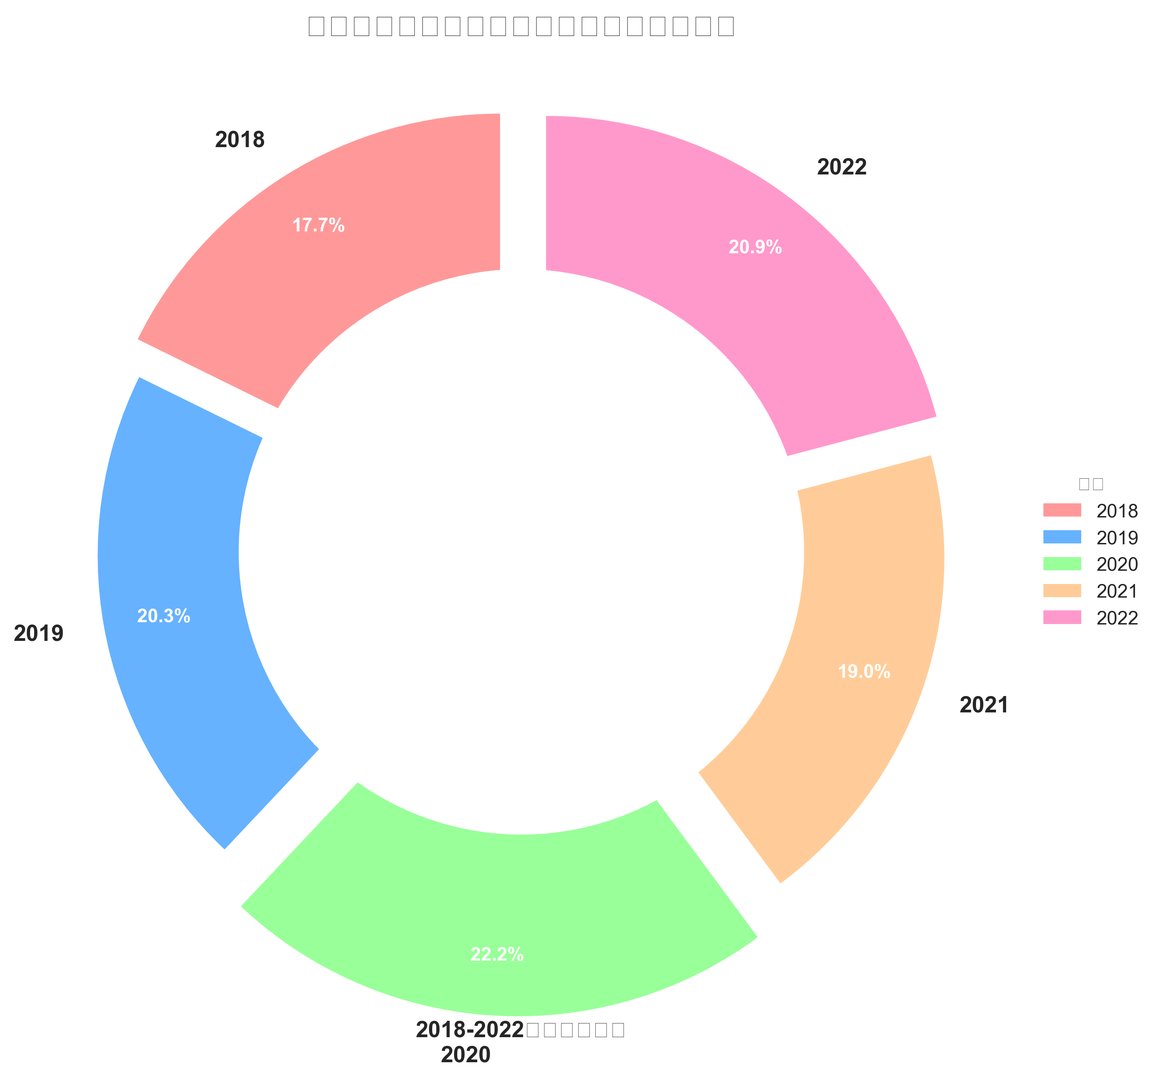五月天專輯銷量在2020年的份額是多少？ 在圖表中，我們可以看到2020年這個年份標籤，並且對應的分段顏色對應了其專輯的銷售份額。圖表上顯示的百分比是35%。
Answer: 35% 哪一年五月天的專輯銷量份額最高？ 圖表中，每年的銷售份額以百分比標註在切片內，35%是最高的，對應於2020年。
Answer: 2020年 從2018年到2022年，五月天專輯銷量份額的平均值是多少？ 我們需要對2018年到2022年的每年份額求平均值：(28% + 32% + 35% + 30% + 33%)/5 = 31.6%。
Answer: 31.6% 哪一年的五月天專輯銷量份額增加最多？ 需要比較兩個相連年份的份額變化，2018年到2019年增加4%，2019年到2020年增加3%，2020年到2021年減少5%，2021年到2022年增加3%。增加最多的是2018年到2019年。
Answer: 2018年到2019年 哪一年的五月天專輯銷量份額相對2018年增長了多少？ 2018年份額是28%，2022年是33%。增長百分比計算：(33% - 28%)/28% = 17.86%。
Answer: 17.86% 五月天專輯銷量份額在2022年與2019年的差距是多少？ 2022年的份額是33%，而2019年是32%。差距計算：33% - 32% = 1%。
Answer: 1% 在2018年至2022年期間，有哪一年五月天專輯銷量份額低於30%？ 分析每個年度的值，只有2018年是28%。
Answer: 2018年 2021年五月天的專輯銷量份額用顏色表示是什麼？ 2021年分段的顏色是淺藍色。
Answer: 淺藍色 